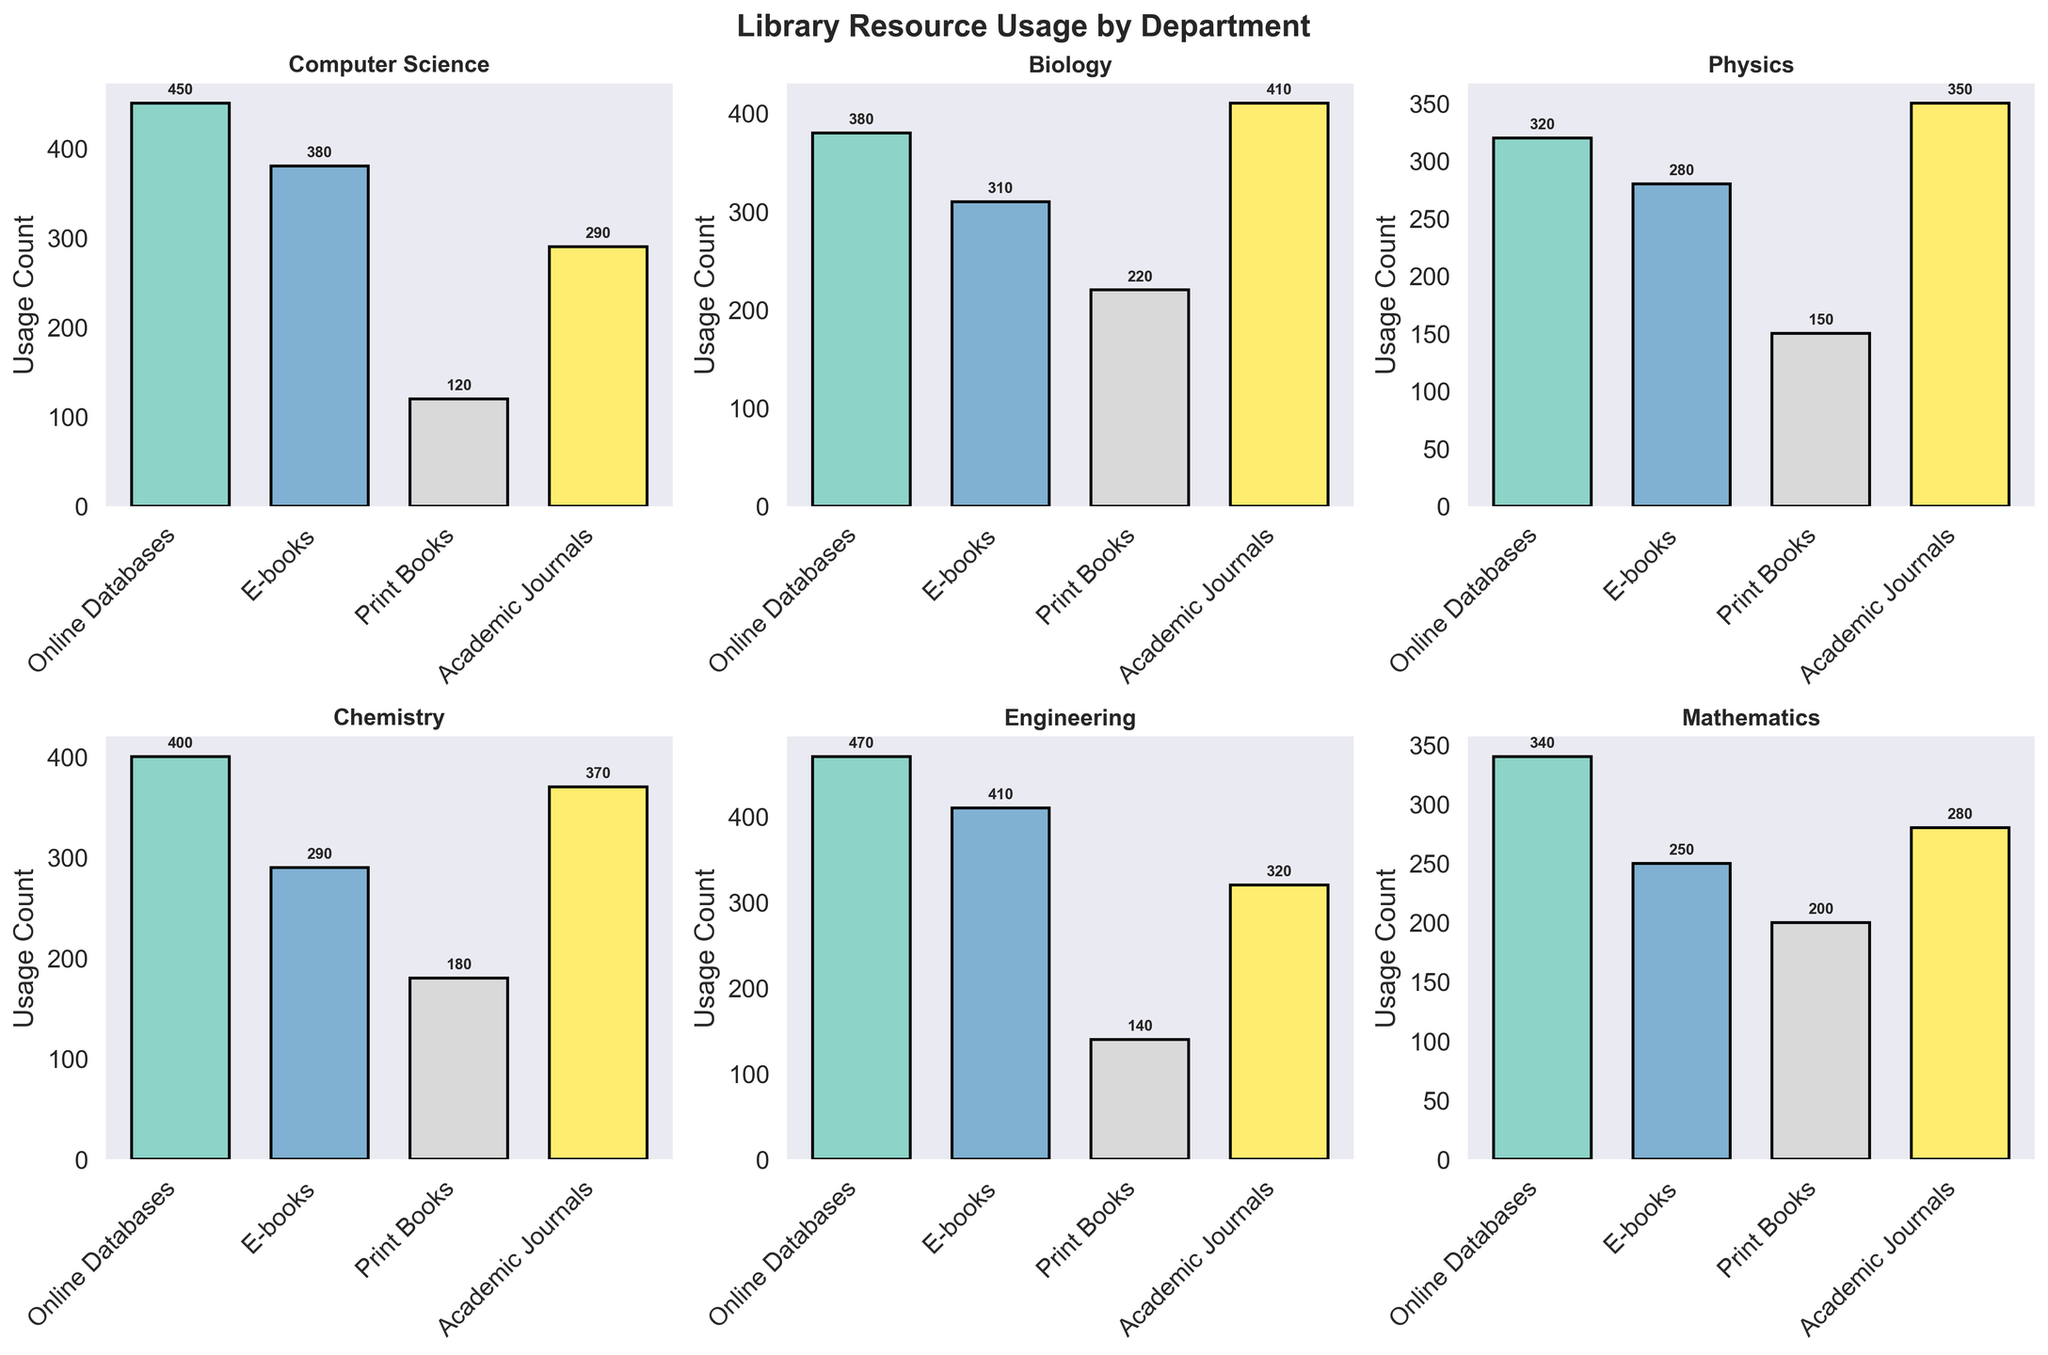What's the title of the figure? The title of the figure is displayed at the top and reads "Library Resource Usage by Department".
Answer: Library Resource Usage by Department Which department has the highest usage count for Online Databases? Referring to the subplots, the highest bar for Online Databases appears in the Engineering department with a usage count of 470.
Answer: Engineering Which two departments have similar usage counts for Print Books? By comparing the height of the bars for Print Books across subplots, Biology and Mathematics have similar usage counts, with 220 and 200 respectively.
Answer: Biology and Mathematics What's the total usage count of E-books across all departments? Summing up the usage counts for E-books from all subplots: (380 Computer Science + 310 Biology + 280 Physics + 290 Chemistry + 410 Engineering + 250 Mathematics) = 1920.
Answer: 1920 Which department has the lowest usage count for Academic Journals and what is the value? The lowest bar for Academic Journals is in the Mathematics department subplot with a value of 280.
Answer: Mathematics, 280 How does the usage of Print Books in Chemistry compare to that in Physics? Comparing the heights of the bars for Print Books, Chemistry has a usage count of 180, which is higher than Physics with a count of 150.
Answer: Chemistry has higher usage What's the average usage count for Online Databases across the departments? Summing the usage counts for Online Databases: (450 + 380 + 320 + 400 + 470 + 340) = 2360. Dividing by the number of departments (6), the average is 2360/6 = 393.33.
Answer: 393.33 In which department is E-books usage count closest to the usage count for Print Books in the same department? We look at each department for the closest values between E-books and Print Books. In Chemistry, the counts are 290 (E-books) and 180 (Print Books), having a difference of 110, which is the smallest difference across departments.
Answer: Chemistry What is the difference between the highest and lowest usage count for Online Databases across departments? The highest count for Online Databases is 470 (Engineering) and the lowest is 320 (Physics). The difference is 470 - 320 = 150.
Answer: 150 